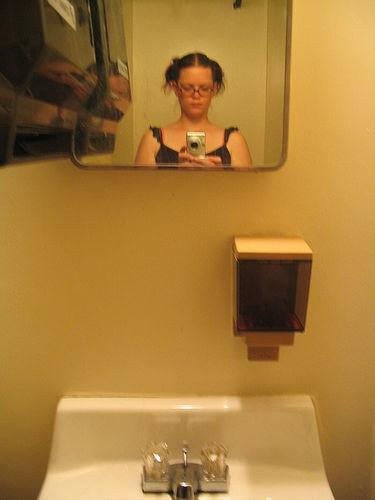Describe the position and appearance of the soap dispenser. The soap dispenser is on the wall, directly above the white sink. It is an orange dispenser with a brown container. Explain what the woman is doing and how she appears in the image. The woman is holding a cellphone in front of a mirror, looking down at it. She has a middle part hairstyle and is wearing eyeglasses. Please provide a general description of the bathroom sink area. The bathroom sink is white and mounted on the light yellow wall beneath a mirror. It includes a small silver faucet, a faucet handle, and a soap dispenser on the wall above it. Describe the central elements of this bathroom scene. A woman holding a cellphone, a white sink with silver faucet, a mirror, and a soap dispenser mounted on the light yellow bathroom wall. Where is the faucet handle located and describe its appearance? The faucet handle is on the sink, and it has a metallic appearance. What is the color and location of the wall in the image? The wall is a light yellow bathroom wall located around the entire scene. Elaborate on the reflection in the mirror. The mirror shows the reflection of the woman wearing glasses and looking down at her cellphone, as well as a camera reflection. Identify the main object on the left side of the image and provide a brief description. A black flat and curved container on the wall, likely a paper towel dispenser. 